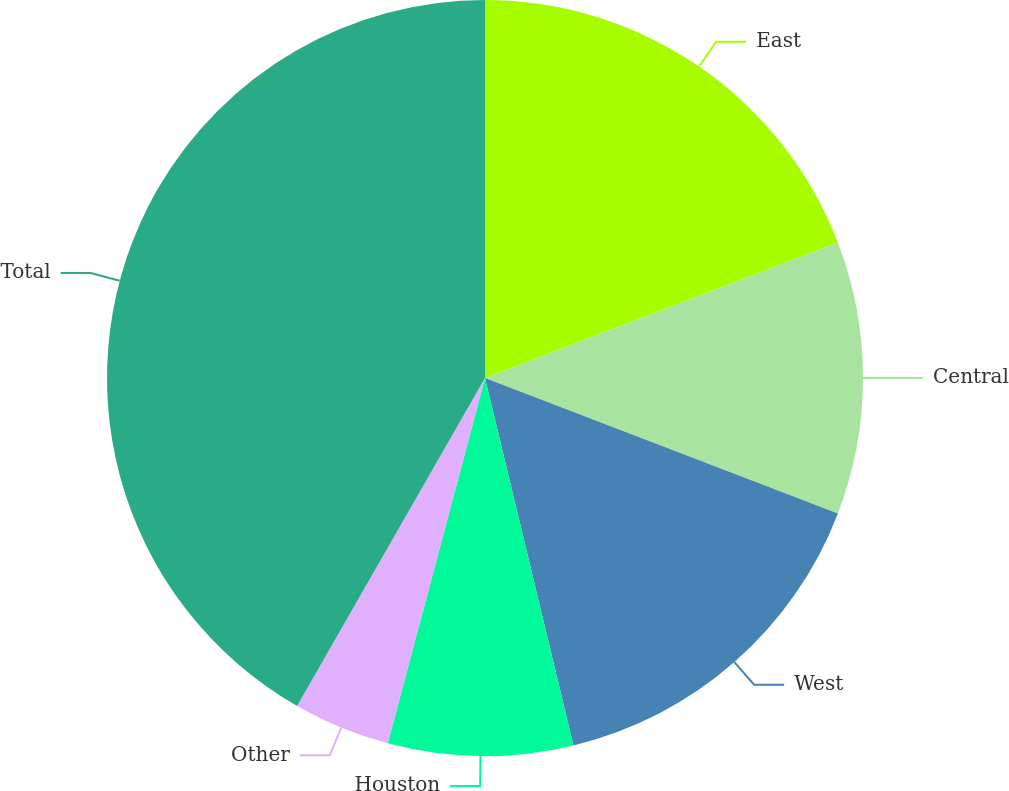Convert chart to OTSL. <chart><loc_0><loc_0><loc_500><loc_500><pie_chart><fcel>East<fcel>Central<fcel>West<fcel>Houston<fcel>Other<fcel>Total<nl><fcel>19.17%<fcel>11.66%<fcel>15.41%<fcel>7.9%<fcel>4.14%<fcel>41.72%<nl></chart> 